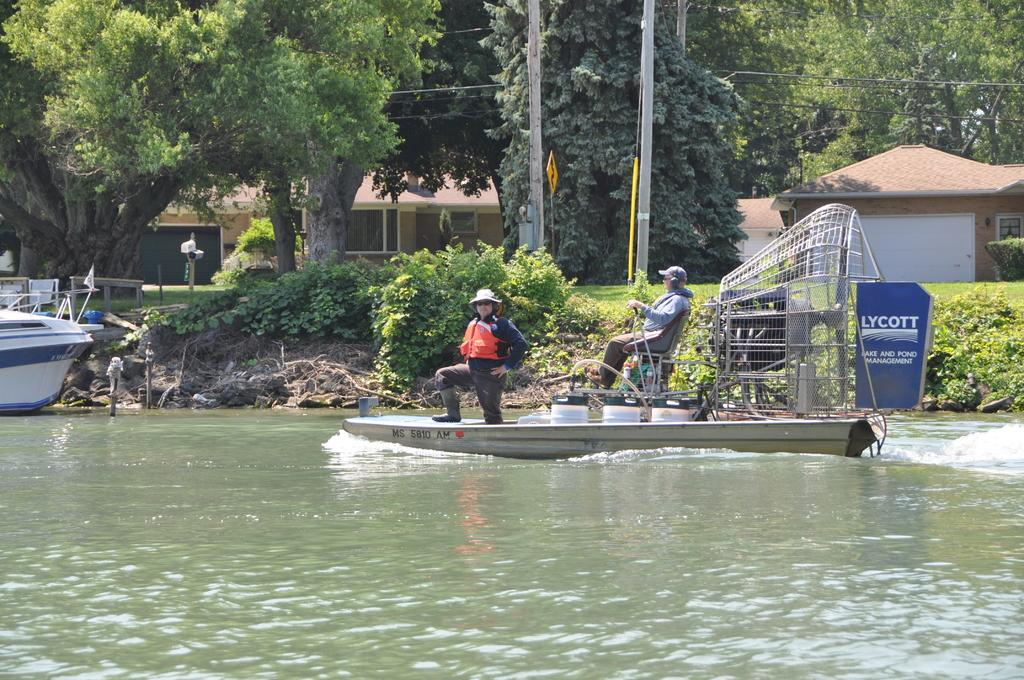What is the main feature of the image? The main feature of the image is water. What is floating on the water? There is a boat in the image. How many people are in the boat? There are two persons in the boat. What type of vegetation can be seen in the image? There are green color plants and trees in the image. What type of structures are visible in the image? There are homes in the image. What color is the chalk used to draw on the sink in the image? There is no chalk or sink present in the image. What type of earth can be seen in the image? The image does not show any earth or soil; it features water, a boat, people, plants, trees, and homes. 